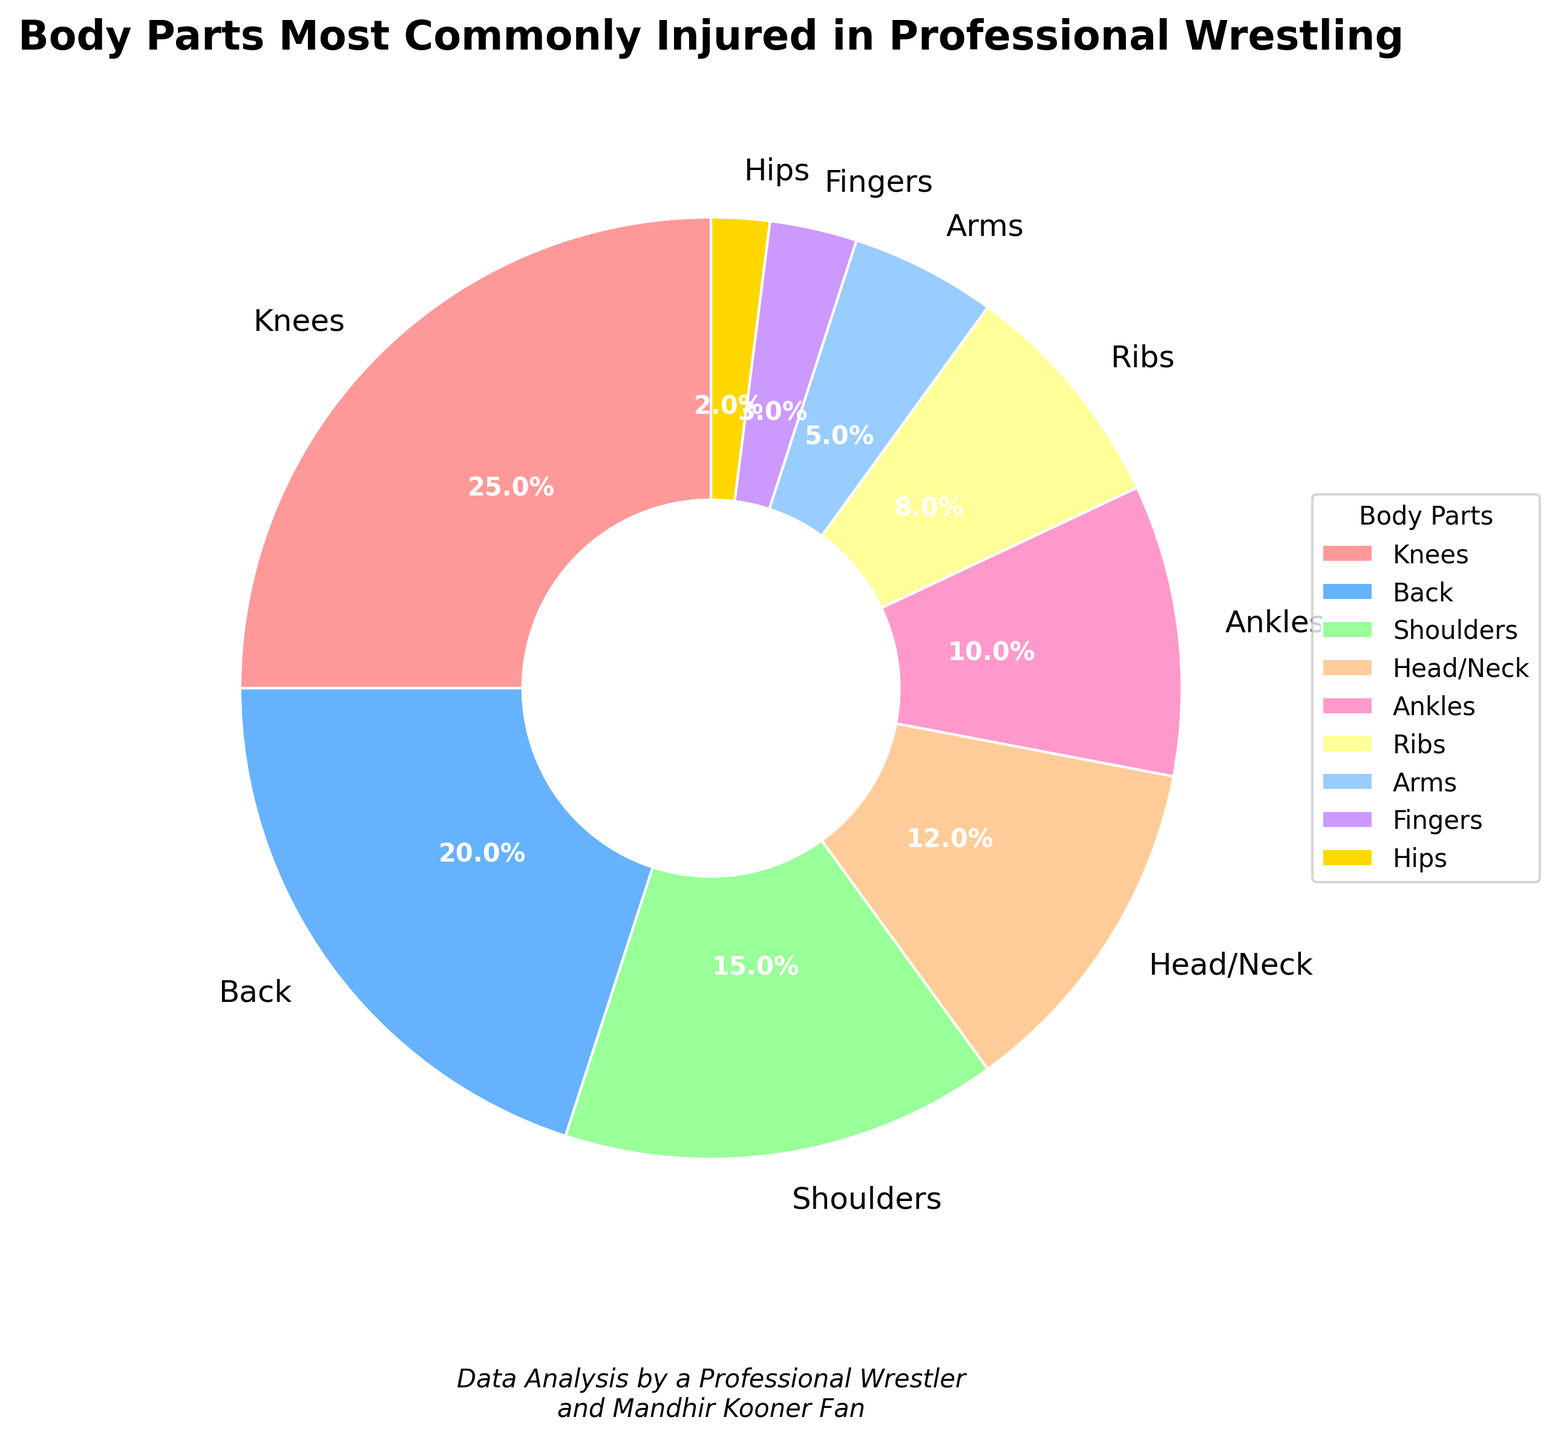Which body part is most commonly injured in professional wrestling? The pie chart shows that the "Knees" segment is the largest, indicating that knees are the most commonly injured body part.
Answer: Knees Which two body parts combined have the highest percentage of injuries? The two largest segments are "Knees" (25%) and "Back" (20%). Adding their percentages, 25% + 20%, gives the highest combined percentage.
Answer: Knees and Back Are the number of injuries for Arms and Hips collectively more than those for Shoulders? Arms account for 5% and hips for 2%, making a combined total of 7%. Shoulders account for 15%. So, 7% is less than 15%.
Answer: No What is the least commonly injured body part? The pie chart indicates that the smallest segment is the "Hips" with 2%.
Answer: Hips Which three body parts contribute to exactly 50% of the injuries? By summing the percentages, "Knees" (25%), "Back" (20%), and "Shoulders" (15%) add up to 60%, which is more than 50%. However, "Knees" (25%), "Back" (20%), and "Head/Neck" (12%) add up to 57%, still more than 50%. On the other hand, "Knees" (25%), "Back" (20%), which together account for 45%, are the closest but do not meet the requirement of 50% exactly. Hence, none perfectly match 50%.
Answer: None How many body parts have an injury percentage less than 10%? The segments "Ribs" (8%), "Arms" (5%), "Fingers" (3%), and "Hips" (2%) are all less than 10%. Counting these, we have 4 segments.
Answer: 4 What is the total percentage of injuries for upper body parts excluding the head/neck? The upper body parts (excluding head/neck) are "Back" (20%), "Shoulders" (15%), "Arms" (5%), and "Ribs" (8%). Adding these, 20% + 15% + 5% + 8% gives 48%.
Answer: 48% Compare the percentage of injuries between the head/neck and ankles. The head/neck section shows 12% and the ankles section shows 10%. So, head/neck is 2% more than ankles.
Answer: Head/Neck has 2% more than Ankles Which body part's injuries are represented with the blue color? By referring to the chart colors, the "Back," which accounts for 20%, is represented in blue.
Answer: Back 